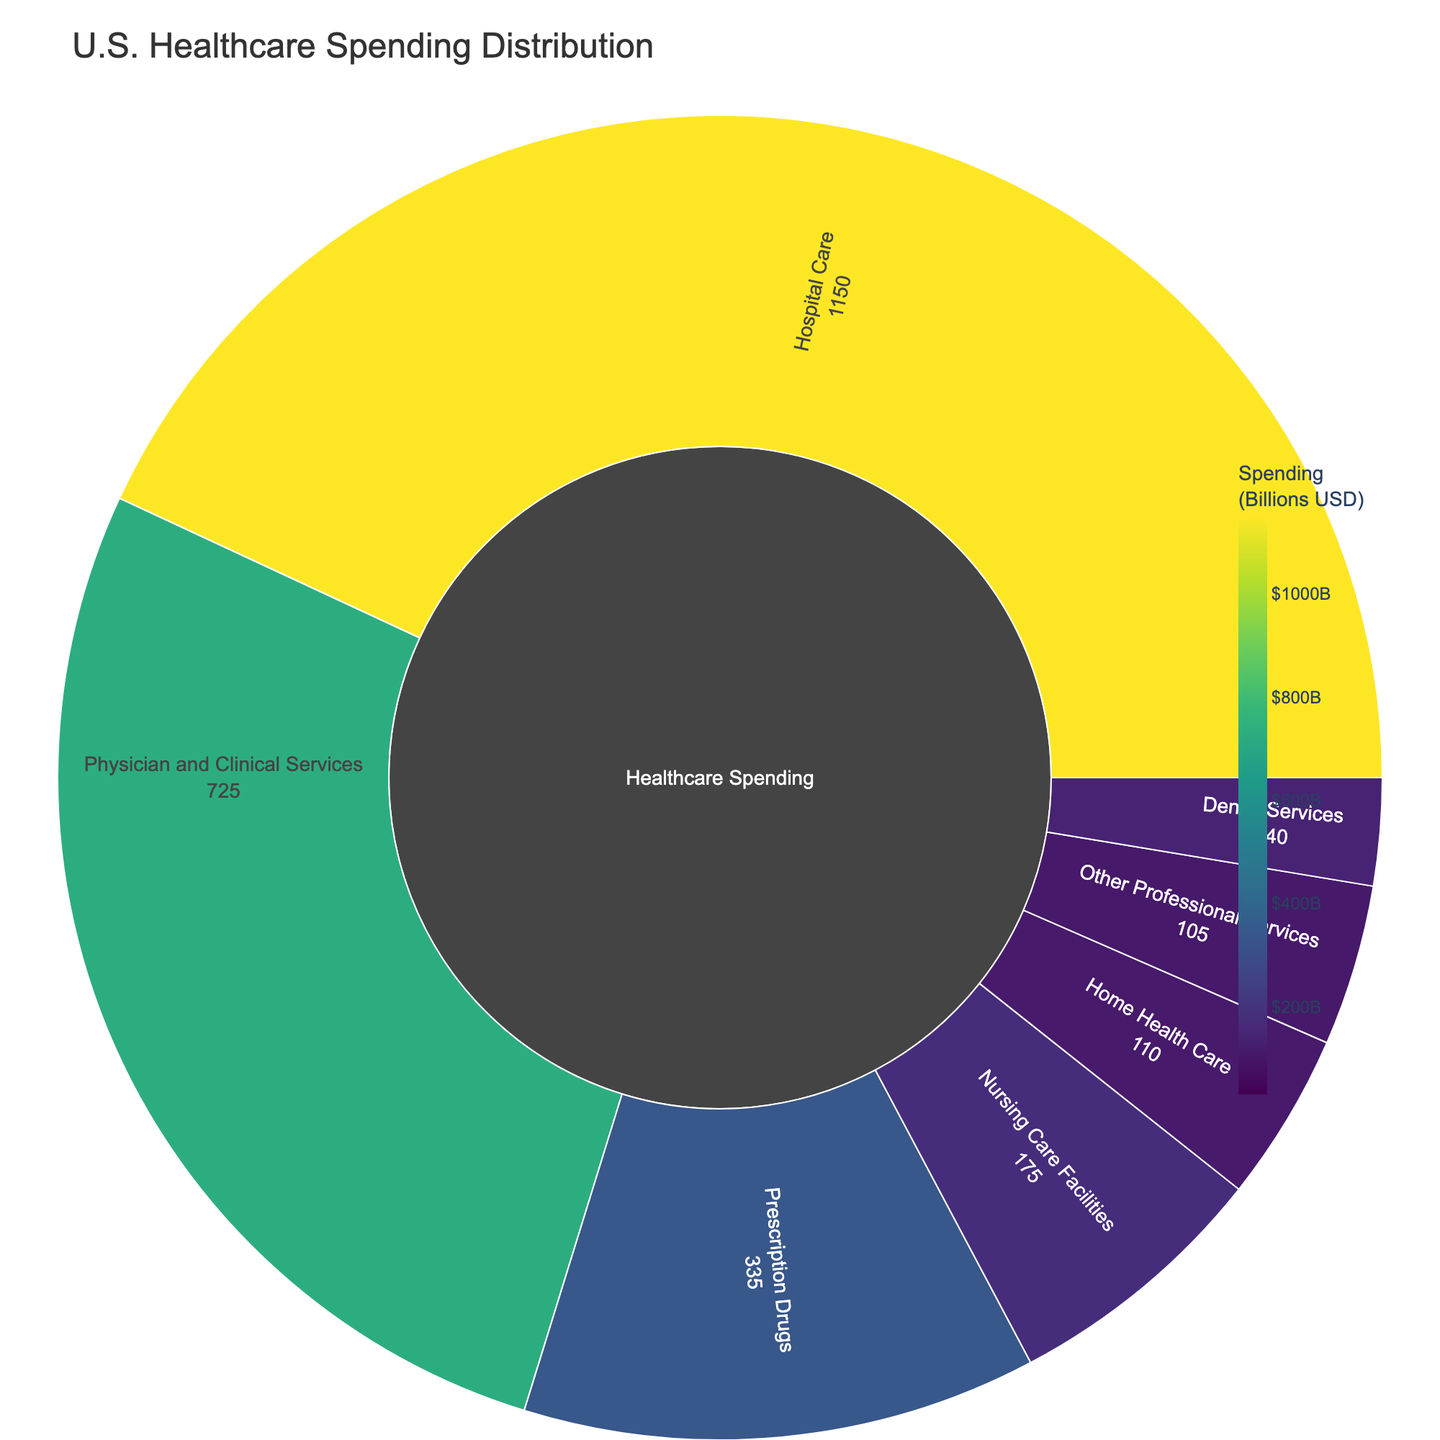what is the largest spending category in the plot? The largest spending category is the one with the highest value in the plot. Looking at the data and the color intensity, Hospital Care has the highest value of 1150 billion USD.
Answer: Hospital Care What is the total spending on Physician and Clinical Services? The total spending on Physician and Clinical Services is the sum of Primary Care and Specialty Care. Adding these values: 300 (Primary Care) + 425 (Specialty Care) = 725 billion USD.
Answer: 725 billion USD Which category has the least spending, and how much is it? By comparing the values of each category, Home Health Care has the least spending with a total value of 110 billion USD.
Answer: Home Health Care, 110 billion USD What is the combined spending on Skilled Nursing across all categories? To find the combined spending on Skilled Nursing, sum the values from both Nursing Care Facilities and Home Health Care. Adding these values: 120 + 65 = 185 billion USD.
Answer: 185 billion USD How does the spending on Brand-name Drugs compare to Generic Drugs? Brand-name Drugs have a higher spending compared to Generic Drugs. Looking at the values in the plot, Brand-name Drugs have 235 billion USD, while Generic Drugs have 100 billion USD.
Answer: Brand-name Drugs are higher Which category within Hospital Care has the highest spending? Within Hospital Care, Inpatient Services has the highest spending with a value of 650 billion USD, compared to Outpatient Services (400 billion USD) and Emergency Services (100 billion USD).
Answer: Inpatient Services What proportion of total Healthcare spending is allocated to Prescription Drugs? The total spending on Healthcare is the sum of all the main categories. Adding their values: 1150 + 725 + 335 + 175 + 140 + 110 + 105 = 2740 billion USD. Prescription Drugs is 335 billion USD. The proportion is 335 / 2740 which is approximately 0.122 or 12.2%.
Answer: 12.2% What's the total spending on Dental Services and Other Professional Services combined? The total spending on Dental Services and Other Professional Services is the sum of their values: 140 (Dental Services) + 105 (Other Professional Services) = 245 billion USD.
Answer: 245 billion USD Which has greater spending: Physical Therapy under Home Health Care or Occupational Therapy under Other Professional Services? Comparing the spending values, Physical Therapy under Home Health Care has 45 billion USD, while Occupational Therapy under Other Professional Services has 40 billion USD. Thus, Physical Therapy has greater spending.
Answer: Physical Therapy Among Other Professional Services, which subcategory has the lowest spending? The subcategories of Other Professional Services are Chiropractic Care, Occupational Therapy, and Speech Therapy. Among these, Speech Therapy has the lowest spending with 30 billion USD.
Answer: Speech Therapy 